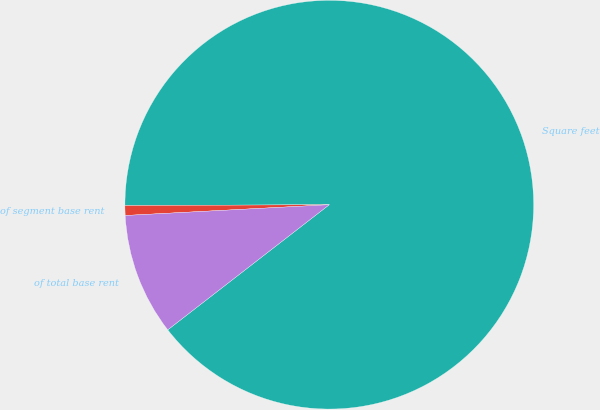Convert chart. <chart><loc_0><loc_0><loc_500><loc_500><pie_chart><fcel>Square feet<fcel>of segment base rent<fcel>of total base rent<nl><fcel>89.58%<fcel>0.77%<fcel>9.65%<nl></chart> 